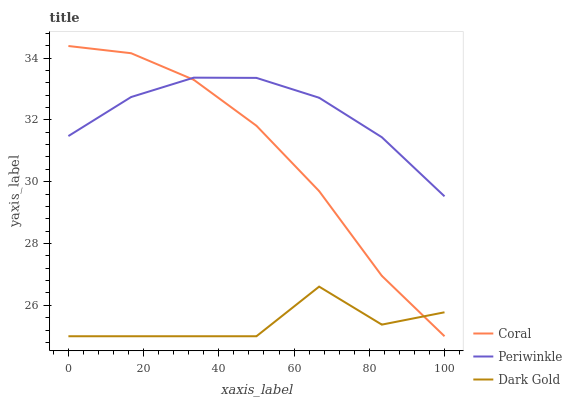Does Dark Gold have the minimum area under the curve?
Answer yes or no. Yes. Does Periwinkle have the maximum area under the curve?
Answer yes or no. Yes. Does Periwinkle have the minimum area under the curve?
Answer yes or no. No. Does Dark Gold have the maximum area under the curve?
Answer yes or no. No. Is Periwinkle the smoothest?
Answer yes or no. Yes. Is Dark Gold the roughest?
Answer yes or no. Yes. Is Dark Gold the smoothest?
Answer yes or no. No. Is Periwinkle the roughest?
Answer yes or no. No. Does Coral have the lowest value?
Answer yes or no. Yes. Does Periwinkle have the lowest value?
Answer yes or no. No. Does Coral have the highest value?
Answer yes or no. Yes. Does Periwinkle have the highest value?
Answer yes or no. No. Is Dark Gold less than Periwinkle?
Answer yes or no. Yes. Is Periwinkle greater than Dark Gold?
Answer yes or no. Yes. Does Coral intersect Dark Gold?
Answer yes or no. Yes. Is Coral less than Dark Gold?
Answer yes or no. No. Is Coral greater than Dark Gold?
Answer yes or no. No. Does Dark Gold intersect Periwinkle?
Answer yes or no. No. 